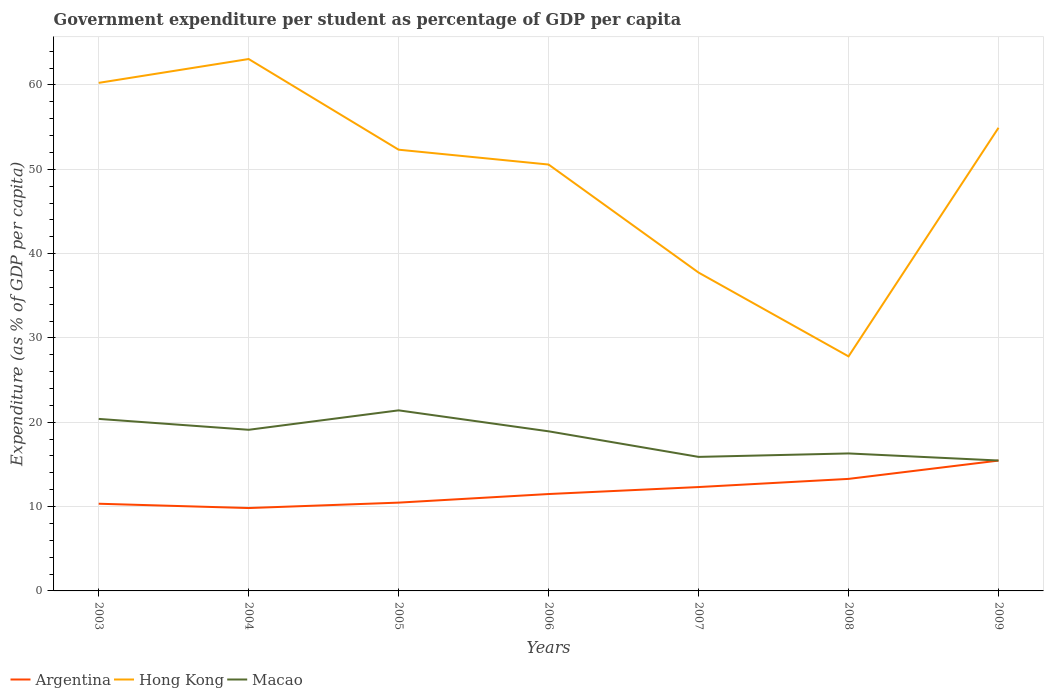Across all years, what is the maximum percentage of expenditure per student in Argentina?
Offer a very short reply. 9.83. In which year was the percentage of expenditure per student in Hong Kong maximum?
Offer a terse response. 2008. What is the total percentage of expenditure per student in Macao in the graph?
Ensure brevity in your answer.  -2.3. What is the difference between the highest and the second highest percentage of expenditure per student in Hong Kong?
Make the answer very short. 35.26. What is the difference between the highest and the lowest percentage of expenditure per student in Argentina?
Your answer should be compact. 3. Is the percentage of expenditure per student in Hong Kong strictly greater than the percentage of expenditure per student in Macao over the years?
Give a very brief answer. No. How many lines are there?
Provide a short and direct response. 3. How many years are there in the graph?
Your response must be concise. 7. What is the difference between two consecutive major ticks on the Y-axis?
Provide a succinct answer. 10. Does the graph contain grids?
Ensure brevity in your answer.  Yes. What is the title of the graph?
Offer a very short reply. Government expenditure per student as percentage of GDP per capita. Does "Haiti" appear as one of the legend labels in the graph?
Your response must be concise. No. What is the label or title of the X-axis?
Offer a terse response. Years. What is the label or title of the Y-axis?
Offer a very short reply. Expenditure (as % of GDP per capita). What is the Expenditure (as % of GDP per capita) of Argentina in 2003?
Ensure brevity in your answer.  10.34. What is the Expenditure (as % of GDP per capita) in Hong Kong in 2003?
Offer a very short reply. 60.25. What is the Expenditure (as % of GDP per capita) in Macao in 2003?
Your answer should be compact. 20.4. What is the Expenditure (as % of GDP per capita) of Argentina in 2004?
Provide a succinct answer. 9.83. What is the Expenditure (as % of GDP per capita) in Hong Kong in 2004?
Make the answer very short. 63.07. What is the Expenditure (as % of GDP per capita) of Macao in 2004?
Provide a short and direct response. 19.11. What is the Expenditure (as % of GDP per capita) of Argentina in 2005?
Offer a terse response. 10.47. What is the Expenditure (as % of GDP per capita) in Hong Kong in 2005?
Your response must be concise. 52.32. What is the Expenditure (as % of GDP per capita) of Macao in 2005?
Provide a succinct answer. 21.41. What is the Expenditure (as % of GDP per capita) in Argentina in 2006?
Keep it short and to the point. 11.49. What is the Expenditure (as % of GDP per capita) of Hong Kong in 2006?
Offer a terse response. 50.56. What is the Expenditure (as % of GDP per capita) in Macao in 2006?
Make the answer very short. 18.93. What is the Expenditure (as % of GDP per capita) in Argentina in 2007?
Offer a very short reply. 12.32. What is the Expenditure (as % of GDP per capita) in Hong Kong in 2007?
Make the answer very short. 37.75. What is the Expenditure (as % of GDP per capita) in Macao in 2007?
Your answer should be very brief. 15.89. What is the Expenditure (as % of GDP per capita) in Argentina in 2008?
Ensure brevity in your answer.  13.29. What is the Expenditure (as % of GDP per capita) in Hong Kong in 2008?
Provide a short and direct response. 27.81. What is the Expenditure (as % of GDP per capita) of Macao in 2008?
Offer a terse response. 16.3. What is the Expenditure (as % of GDP per capita) in Argentina in 2009?
Offer a very short reply. 15.46. What is the Expenditure (as % of GDP per capita) of Hong Kong in 2009?
Offer a terse response. 54.92. What is the Expenditure (as % of GDP per capita) in Macao in 2009?
Your answer should be compact. 15.46. Across all years, what is the maximum Expenditure (as % of GDP per capita) in Argentina?
Provide a short and direct response. 15.46. Across all years, what is the maximum Expenditure (as % of GDP per capita) of Hong Kong?
Make the answer very short. 63.07. Across all years, what is the maximum Expenditure (as % of GDP per capita) in Macao?
Keep it short and to the point. 21.41. Across all years, what is the minimum Expenditure (as % of GDP per capita) of Argentina?
Offer a terse response. 9.83. Across all years, what is the minimum Expenditure (as % of GDP per capita) of Hong Kong?
Keep it short and to the point. 27.81. Across all years, what is the minimum Expenditure (as % of GDP per capita) of Macao?
Ensure brevity in your answer.  15.46. What is the total Expenditure (as % of GDP per capita) of Argentina in the graph?
Provide a succinct answer. 83.19. What is the total Expenditure (as % of GDP per capita) in Hong Kong in the graph?
Ensure brevity in your answer.  346.69. What is the total Expenditure (as % of GDP per capita) of Macao in the graph?
Provide a short and direct response. 127.51. What is the difference between the Expenditure (as % of GDP per capita) in Argentina in 2003 and that in 2004?
Provide a short and direct response. 0.51. What is the difference between the Expenditure (as % of GDP per capita) of Hong Kong in 2003 and that in 2004?
Your response must be concise. -2.83. What is the difference between the Expenditure (as % of GDP per capita) in Macao in 2003 and that in 2004?
Offer a very short reply. 1.29. What is the difference between the Expenditure (as % of GDP per capita) of Argentina in 2003 and that in 2005?
Make the answer very short. -0.13. What is the difference between the Expenditure (as % of GDP per capita) in Hong Kong in 2003 and that in 2005?
Offer a very short reply. 7.93. What is the difference between the Expenditure (as % of GDP per capita) of Macao in 2003 and that in 2005?
Your answer should be very brief. -1.01. What is the difference between the Expenditure (as % of GDP per capita) of Argentina in 2003 and that in 2006?
Give a very brief answer. -1.15. What is the difference between the Expenditure (as % of GDP per capita) of Hong Kong in 2003 and that in 2006?
Your answer should be compact. 9.69. What is the difference between the Expenditure (as % of GDP per capita) in Macao in 2003 and that in 2006?
Offer a terse response. 1.47. What is the difference between the Expenditure (as % of GDP per capita) in Argentina in 2003 and that in 2007?
Give a very brief answer. -1.98. What is the difference between the Expenditure (as % of GDP per capita) of Hong Kong in 2003 and that in 2007?
Your answer should be very brief. 22.5. What is the difference between the Expenditure (as % of GDP per capita) in Macao in 2003 and that in 2007?
Make the answer very short. 4.5. What is the difference between the Expenditure (as % of GDP per capita) in Argentina in 2003 and that in 2008?
Offer a very short reply. -2.95. What is the difference between the Expenditure (as % of GDP per capita) in Hong Kong in 2003 and that in 2008?
Your answer should be compact. 32.44. What is the difference between the Expenditure (as % of GDP per capita) of Macao in 2003 and that in 2008?
Your answer should be compact. 4.1. What is the difference between the Expenditure (as % of GDP per capita) in Argentina in 2003 and that in 2009?
Provide a succinct answer. -5.12. What is the difference between the Expenditure (as % of GDP per capita) in Hong Kong in 2003 and that in 2009?
Your answer should be compact. 5.33. What is the difference between the Expenditure (as % of GDP per capita) in Macao in 2003 and that in 2009?
Offer a very short reply. 4.93. What is the difference between the Expenditure (as % of GDP per capita) in Argentina in 2004 and that in 2005?
Provide a short and direct response. -0.64. What is the difference between the Expenditure (as % of GDP per capita) in Hong Kong in 2004 and that in 2005?
Keep it short and to the point. 10.75. What is the difference between the Expenditure (as % of GDP per capita) of Macao in 2004 and that in 2005?
Offer a very short reply. -2.3. What is the difference between the Expenditure (as % of GDP per capita) in Argentina in 2004 and that in 2006?
Provide a succinct answer. -1.66. What is the difference between the Expenditure (as % of GDP per capita) in Hong Kong in 2004 and that in 2006?
Offer a very short reply. 12.51. What is the difference between the Expenditure (as % of GDP per capita) of Macao in 2004 and that in 2006?
Provide a succinct answer. 0.18. What is the difference between the Expenditure (as % of GDP per capita) of Argentina in 2004 and that in 2007?
Your response must be concise. -2.49. What is the difference between the Expenditure (as % of GDP per capita) in Hong Kong in 2004 and that in 2007?
Provide a succinct answer. 25.32. What is the difference between the Expenditure (as % of GDP per capita) in Macao in 2004 and that in 2007?
Keep it short and to the point. 3.21. What is the difference between the Expenditure (as % of GDP per capita) of Argentina in 2004 and that in 2008?
Your answer should be very brief. -3.46. What is the difference between the Expenditure (as % of GDP per capita) of Hong Kong in 2004 and that in 2008?
Your answer should be compact. 35.26. What is the difference between the Expenditure (as % of GDP per capita) in Macao in 2004 and that in 2008?
Your response must be concise. 2.8. What is the difference between the Expenditure (as % of GDP per capita) in Argentina in 2004 and that in 2009?
Provide a succinct answer. -5.63. What is the difference between the Expenditure (as % of GDP per capita) of Hong Kong in 2004 and that in 2009?
Keep it short and to the point. 8.15. What is the difference between the Expenditure (as % of GDP per capita) of Macao in 2004 and that in 2009?
Your answer should be compact. 3.64. What is the difference between the Expenditure (as % of GDP per capita) of Argentina in 2005 and that in 2006?
Give a very brief answer. -1.02. What is the difference between the Expenditure (as % of GDP per capita) in Hong Kong in 2005 and that in 2006?
Offer a terse response. 1.76. What is the difference between the Expenditure (as % of GDP per capita) of Macao in 2005 and that in 2006?
Give a very brief answer. 2.49. What is the difference between the Expenditure (as % of GDP per capita) of Argentina in 2005 and that in 2007?
Offer a terse response. -1.85. What is the difference between the Expenditure (as % of GDP per capita) in Hong Kong in 2005 and that in 2007?
Provide a succinct answer. 14.57. What is the difference between the Expenditure (as % of GDP per capita) in Macao in 2005 and that in 2007?
Make the answer very short. 5.52. What is the difference between the Expenditure (as % of GDP per capita) in Argentina in 2005 and that in 2008?
Keep it short and to the point. -2.81. What is the difference between the Expenditure (as % of GDP per capita) in Hong Kong in 2005 and that in 2008?
Offer a terse response. 24.51. What is the difference between the Expenditure (as % of GDP per capita) in Macao in 2005 and that in 2008?
Give a very brief answer. 5.11. What is the difference between the Expenditure (as % of GDP per capita) in Argentina in 2005 and that in 2009?
Your answer should be compact. -4.98. What is the difference between the Expenditure (as % of GDP per capita) of Hong Kong in 2005 and that in 2009?
Offer a very short reply. -2.6. What is the difference between the Expenditure (as % of GDP per capita) of Macao in 2005 and that in 2009?
Offer a very short reply. 5.95. What is the difference between the Expenditure (as % of GDP per capita) in Argentina in 2006 and that in 2007?
Offer a very short reply. -0.83. What is the difference between the Expenditure (as % of GDP per capita) of Hong Kong in 2006 and that in 2007?
Keep it short and to the point. 12.81. What is the difference between the Expenditure (as % of GDP per capita) of Macao in 2006 and that in 2007?
Your answer should be compact. 3.03. What is the difference between the Expenditure (as % of GDP per capita) of Argentina in 2006 and that in 2008?
Offer a very short reply. -1.8. What is the difference between the Expenditure (as % of GDP per capita) of Hong Kong in 2006 and that in 2008?
Offer a very short reply. 22.75. What is the difference between the Expenditure (as % of GDP per capita) of Macao in 2006 and that in 2008?
Your response must be concise. 2.62. What is the difference between the Expenditure (as % of GDP per capita) of Argentina in 2006 and that in 2009?
Keep it short and to the point. -3.97. What is the difference between the Expenditure (as % of GDP per capita) in Hong Kong in 2006 and that in 2009?
Provide a short and direct response. -4.36. What is the difference between the Expenditure (as % of GDP per capita) of Macao in 2006 and that in 2009?
Your answer should be compact. 3.46. What is the difference between the Expenditure (as % of GDP per capita) of Argentina in 2007 and that in 2008?
Provide a short and direct response. -0.97. What is the difference between the Expenditure (as % of GDP per capita) of Hong Kong in 2007 and that in 2008?
Your answer should be compact. 9.94. What is the difference between the Expenditure (as % of GDP per capita) of Macao in 2007 and that in 2008?
Give a very brief answer. -0.41. What is the difference between the Expenditure (as % of GDP per capita) in Argentina in 2007 and that in 2009?
Make the answer very short. -3.14. What is the difference between the Expenditure (as % of GDP per capita) in Hong Kong in 2007 and that in 2009?
Keep it short and to the point. -17.17. What is the difference between the Expenditure (as % of GDP per capita) of Macao in 2007 and that in 2009?
Ensure brevity in your answer.  0.43. What is the difference between the Expenditure (as % of GDP per capita) of Argentina in 2008 and that in 2009?
Offer a terse response. -2.17. What is the difference between the Expenditure (as % of GDP per capita) of Hong Kong in 2008 and that in 2009?
Offer a very short reply. -27.11. What is the difference between the Expenditure (as % of GDP per capita) of Macao in 2008 and that in 2009?
Ensure brevity in your answer.  0.84. What is the difference between the Expenditure (as % of GDP per capita) in Argentina in 2003 and the Expenditure (as % of GDP per capita) in Hong Kong in 2004?
Your answer should be compact. -52.74. What is the difference between the Expenditure (as % of GDP per capita) in Argentina in 2003 and the Expenditure (as % of GDP per capita) in Macao in 2004?
Keep it short and to the point. -8.77. What is the difference between the Expenditure (as % of GDP per capita) in Hong Kong in 2003 and the Expenditure (as % of GDP per capita) in Macao in 2004?
Make the answer very short. 41.14. What is the difference between the Expenditure (as % of GDP per capita) in Argentina in 2003 and the Expenditure (as % of GDP per capita) in Hong Kong in 2005?
Offer a terse response. -41.98. What is the difference between the Expenditure (as % of GDP per capita) in Argentina in 2003 and the Expenditure (as % of GDP per capita) in Macao in 2005?
Provide a short and direct response. -11.07. What is the difference between the Expenditure (as % of GDP per capita) in Hong Kong in 2003 and the Expenditure (as % of GDP per capita) in Macao in 2005?
Provide a short and direct response. 38.83. What is the difference between the Expenditure (as % of GDP per capita) of Argentina in 2003 and the Expenditure (as % of GDP per capita) of Hong Kong in 2006?
Offer a very short reply. -40.22. What is the difference between the Expenditure (as % of GDP per capita) of Argentina in 2003 and the Expenditure (as % of GDP per capita) of Macao in 2006?
Offer a very short reply. -8.59. What is the difference between the Expenditure (as % of GDP per capita) in Hong Kong in 2003 and the Expenditure (as % of GDP per capita) in Macao in 2006?
Offer a very short reply. 41.32. What is the difference between the Expenditure (as % of GDP per capita) of Argentina in 2003 and the Expenditure (as % of GDP per capita) of Hong Kong in 2007?
Your response must be concise. -27.41. What is the difference between the Expenditure (as % of GDP per capita) of Argentina in 2003 and the Expenditure (as % of GDP per capita) of Macao in 2007?
Provide a succinct answer. -5.56. What is the difference between the Expenditure (as % of GDP per capita) in Hong Kong in 2003 and the Expenditure (as % of GDP per capita) in Macao in 2007?
Keep it short and to the point. 44.35. What is the difference between the Expenditure (as % of GDP per capita) in Argentina in 2003 and the Expenditure (as % of GDP per capita) in Hong Kong in 2008?
Ensure brevity in your answer.  -17.47. What is the difference between the Expenditure (as % of GDP per capita) in Argentina in 2003 and the Expenditure (as % of GDP per capita) in Macao in 2008?
Offer a terse response. -5.96. What is the difference between the Expenditure (as % of GDP per capita) in Hong Kong in 2003 and the Expenditure (as % of GDP per capita) in Macao in 2008?
Your response must be concise. 43.94. What is the difference between the Expenditure (as % of GDP per capita) in Argentina in 2003 and the Expenditure (as % of GDP per capita) in Hong Kong in 2009?
Offer a very short reply. -44.58. What is the difference between the Expenditure (as % of GDP per capita) of Argentina in 2003 and the Expenditure (as % of GDP per capita) of Macao in 2009?
Offer a terse response. -5.13. What is the difference between the Expenditure (as % of GDP per capita) of Hong Kong in 2003 and the Expenditure (as % of GDP per capita) of Macao in 2009?
Ensure brevity in your answer.  44.78. What is the difference between the Expenditure (as % of GDP per capita) of Argentina in 2004 and the Expenditure (as % of GDP per capita) of Hong Kong in 2005?
Your answer should be compact. -42.49. What is the difference between the Expenditure (as % of GDP per capita) in Argentina in 2004 and the Expenditure (as % of GDP per capita) in Macao in 2005?
Give a very brief answer. -11.59. What is the difference between the Expenditure (as % of GDP per capita) of Hong Kong in 2004 and the Expenditure (as % of GDP per capita) of Macao in 2005?
Your answer should be very brief. 41.66. What is the difference between the Expenditure (as % of GDP per capita) in Argentina in 2004 and the Expenditure (as % of GDP per capita) in Hong Kong in 2006?
Keep it short and to the point. -40.73. What is the difference between the Expenditure (as % of GDP per capita) of Argentina in 2004 and the Expenditure (as % of GDP per capita) of Macao in 2006?
Give a very brief answer. -9.1. What is the difference between the Expenditure (as % of GDP per capita) of Hong Kong in 2004 and the Expenditure (as % of GDP per capita) of Macao in 2006?
Your response must be concise. 44.15. What is the difference between the Expenditure (as % of GDP per capita) in Argentina in 2004 and the Expenditure (as % of GDP per capita) in Hong Kong in 2007?
Provide a short and direct response. -27.92. What is the difference between the Expenditure (as % of GDP per capita) in Argentina in 2004 and the Expenditure (as % of GDP per capita) in Macao in 2007?
Give a very brief answer. -6.07. What is the difference between the Expenditure (as % of GDP per capita) of Hong Kong in 2004 and the Expenditure (as % of GDP per capita) of Macao in 2007?
Provide a succinct answer. 47.18. What is the difference between the Expenditure (as % of GDP per capita) of Argentina in 2004 and the Expenditure (as % of GDP per capita) of Hong Kong in 2008?
Your answer should be compact. -17.98. What is the difference between the Expenditure (as % of GDP per capita) in Argentina in 2004 and the Expenditure (as % of GDP per capita) in Macao in 2008?
Your answer should be compact. -6.48. What is the difference between the Expenditure (as % of GDP per capita) in Hong Kong in 2004 and the Expenditure (as % of GDP per capita) in Macao in 2008?
Provide a short and direct response. 46.77. What is the difference between the Expenditure (as % of GDP per capita) of Argentina in 2004 and the Expenditure (as % of GDP per capita) of Hong Kong in 2009?
Offer a terse response. -45.09. What is the difference between the Expenditure (as % of GDP per capita) of Argentina in 2004 and the Expenditure (as % of GDP per capita) of Macao in 2009?
Keep it short and to the point. -5.64. What is the difference between the Expenditure (as % of GDP per capita) in Hong Kong in 2004 and the Expenditure (as % of GDP per capita) in Macao in 2009?
Offer a terse response. 47.61. What is the difference between the Expenditure (as % of GDP per capita) in Argentina in 2005 and the Expenditure (as % of GDP per capita) in Hong Kong in 2006?
Make the answer very short. -40.09. What is the difference between the Expenditure (as % of GDP per capita) in Argentina in 2005 and the Expenditure (as % of GDP per capita) in Macao in 2006?
Ensure brevity in your answer.  -8.46. What is the difference between the Expenditure (as % of GDP per capita) of Hong Kong in 2005 and the Expenditure (as % of GDP per capita) of Macao in 2006?
Provide a short and direct response. 33.4. What is the difference between the Expenditure (as % of GDP per capita) in Argentina in 2005 and the Expenditure (as % of GDP per capita) in Hong Kong in 2007?
Your answer should be compact. -27.28. What is the difference between the Expenditure (as % of GDP per capita) in Argentina in 2005 and the Expenditure (as % of GDP per capita) in Macao in 2007?
Provide a succinct answer. -5.42. What is the difference between the Expenditure (as % of GDP per capita) of Hong Kong in 2005 and the Expenditure (as % of GDP per capita) of Macao in 2007?
Ensure brevity in your answer.  36.43. What is the difference between the Expenditure (as % of GDP per capita) of Argentina in 2005 and the Expenditure (as % of GDP per capita) of Hong Kong in 2008?
Your answer should be compact. -17.34. What is the difference between the Expenditure (as % of GDP per capita) of Argentina in 2005 and the Expenditure (as % of GDP per capita) of Macao in 2008?
Give a very brief answer. -5.83. What is the difference between the Expenditure (as % of GDP per capita) in Hong Kong in 2005 and the Expenditure (as % of GDP per capita) in Macao in 2008?
Provide a short and direct response. 36.02. What is the difference between the Expenditure (as % of GDP per capita) of Argentina in 2005 and the Expenditure (as % of GDP per capita) of Hong Kong in 2009?
Make the answer very short. -44.45. What is the difference between the Expenditure (as % of GDP per capita) in Argentina in 2005 and the Expenditure (as % of GDP per capita) in Macao in 2009?
Your answer should be compact. -4.99. What is the difference between the Expenditure (as % of GDP per capita) of Hong Kong in 2005 and the Expenditure (as % of GDP per capita) of Macao in 2009?
Provide a succinct answer. 36.86. What is the difference between the Expenditure (as % of GDP per capita) of Argentina in 2006 and the Expenditure (as % of GDP per capita) of Hong Kong in 2007?
Your answer should be very brief. -26.26. What is the difference between the Expenditure (as % of GDP per capita) of Argentina in 2006 and the Expenditure (as % of GDP per capita) of Macao in 2007?
Ensure brevity in your answer.  -4.41. What is the difference between the Expenditure (as % of GDP per capita) in Hong Kong in 2006 and the Expenditure (as % of GDP per capita) in Macao in 2007?
Your answer should be compact. 34.67. What is the difference between the Expenditure (as % of GDP per capita) in Argentina in 2006 and the Expenditure (as % of GDP per capita) in Hong Kong in 2008?
Give a very brief answer. -16.32. What is the difference between the Expenditure (as % of GDP per capita) in Argentina in 2006 and the Expenditure (as % of GDP per capita) in Macao in 2008?
Offer a terse response. -4.81. What is the difference between the Expenditure (as % of GDP per capita) in Hong Kong in 2006 and the Expenditure (as % of GDP per capita) in Macao in 2008?
Your answer should be compact. 34.26. What is the difference between the Expenditure (as % of GDP per capita) in Argentina in 2006 and the Expenditure (as % of GDP per capita) in Hong Kong in 2009?
Make the answer very short. -43.43. What is the difference between the Expenditure (as % of GDP per capita) in Argentina in 2006 and the Expenditure (as % of GDP per capita) in Macao in 2009?
Make the answer very short. -3.98. What is the difference between the Expenditure (as % of GDP per capita) of Hong Kong in 2006 and the Expenditure (as % of GDP per capita) of Macao in 2009?
Your response must be concise. 35.1. What is the difference between the Expenditure (as % of GDP per capita) in Argentina in 2007 and the Expenditure (as % of GDP per capita) in Hong Kong in 2008?
Provide a succinct answer. -15.49. What is the difference between the Expenditure (as % of GDP per capita) in Argentina in 2007 and the Expenditure (as % of GDP per capita) in Macao in 2008?
Make the answer very short. -3.99. What is the difference between the Expenditure (as % of GDP per capita) of Hong Kong in 2007 and the Expenditure (as % of GDP per capita) of Macao in 2008?
Your response must be concise. 21.45. What is the difference between the Expenditure (as % of GDP per capita) in Argentina in 2007 and the Expenditure (as % of GDP per capita) in Hong Kong in 2009?
Provide a short and direct response. -42.6. What is the difference between the Expenditure (as % of GDP per capita) of Argentina in 2007 and the Expenditure (as % of GDP per capita) of Macao in 2009?
Provide a succinct answer. -3.15. What is the difference between the Expenditure (as % of GDP per capita) of Hong Kong in 2007 and the Expenditure (as % of GDP per capita) of Macao in 2009?
Provide a succinct answer. 22.29. What is the difference between the Expenditure (as % of GDP per capita) in Argentina in 2008 and the Expenditure (as % of GDP per capita) in Hong Kong in 2009?
Offer a very short reply. -41.64. What is the difference between the Expenditure (as % of GDP per capita) of Argentina in 2008 and the Expenditure (as % of GDP per capita) of Macao in 2009?
Provide a succinct answer. -2.18. What is the difference between the Expenditure (as % of GDP per capita) in Hong Kong in 2008 and the Expenditure (as % of GDP per capita) in Macao in 2009?
Offer a terse response. 12.35. What is the average Expenditure (as % of GDP per capita) in Argentina per year?
Your response must be concise. 11.88. What is the average Expenditure (as % of GDP per capita) in Hong Kong per year?
Offer a very short reply. 49.53. What is the average Expenditure (as % of GDP per capita) of Macao per year?
Offer a very short reply. 18.22. In the year 2003, what is the difference between the Expenditure (as % of GDP per capita) in Argentina and Expenditure (as % of GDP per capita) in Hong Kong?
Offer a terse response. -49.91. In the year 2003, what is the difference between the Expenditure (as % of GDP per capita) in Argentina and Expenditure (as % of GDP per capita) in Macao?
Provide a short and direct response. -10.06. In the year 2003, what is the difference between the Expenditure (as % of GDP per capita) in Hong Kong and Expenditure (as % of GDP per capita) in Macao?
Offer a terse response. 39.85. In the year 2004, what is the difference between the Expenditure (as % of GDP per capita) in Argentina and Expenditure (as % of GDP per capita) in Hong Kong?
Make the answer very short. -53.25. In the year 2004, what is the difference between the Expenditure (as % of GDP per capita) in Argentina and Expenditure (as % of GDP per capita) in Macao?
Offer a very short reply. -9.28. In the year 2004, what is the difference between the Expenditure (as % of GDP per capita) in Hong Kong and Expenditure (as % of GDP per capita) in Macao?
Keep it short and to the point. 43.97. In the year 2005, what is the difference between the Expenditure (as % of GDP per capita) in Argentina and Expenditure (as % of GDP per capita) in Hong Kong?
Keep it short and to the point. -41.85. In the year 2005, what is the difference between the Expenditure (as % of GDP per capita) of Argentina and Expenditure (as % of GDP per capita) of Macao?
Offer a terse response. -10.94. In the year 2005, what is the difference between the Expenditure (as % of GDP per capita) of Hong Kong and Expenditure (as % of GDP per capita) of Macao?
Offer a terse response. 30.91. In the year 2006, what is the difference between the Expenditure (as % of GDP per capita) in Argentina and Expenditure (as % of GDP per capita) in Hong Kong?
Your answer should be very brief. -39.07. In the year 2006, what is the difference between the Expenditure (as % of GDP per capita) in Argentina and Expenditure (as % of GDP per capita) in Macao?
Your answer should be very brief. -7.44. In the year 2006, what is the difference between the Expenditure (as % of GDP per capita) in Hong Kong and Expenditure (as % of GDP per capita) in Macao?
Your answer should be very brief. 31.64. In the year 2007, what is the difference between the Expenditure (as % of GDP per capita) of Argentina and Expenditure (as % of GDP per capita) of Hong Kong?
Provide a short and direct response. -25.43. In the year 2007, what is the difference between the Expenditure (as % of GDP per capita) in Argentina and Expenditure (as % of GDP per capita) in Macao?
Your answer should be very brief. -3.58. In the year 2007, what is the difference between the Expenditure (as % of GDP per capita) in Hong Kong and Expenditure (as % of GDP per capita) in Macao?
Your answer should be very brief. 21.86. In the year 2008, what is the difference between the Expenditure (as % of GDP per capita) of Argentina and Expenditure (as % of GDP per capita) of Hong Kong?
Ensure brevity in your answer.  -14.53. In the year 2008, what is the difference between the Expenditure (as % of GDP per capita) in Argentina and Expenditure (as % of GDP per capita) in Macao?
Your response must be concise. -3.02. In the year 2008, what is the difference between the Expenditure (as % of GDP per capita) of Hong Kong and Expenditure (as % of GDP per capita) of Macao?
Ensure brevity in your answer.  11.51. In the year 2009, what is the difference between the Expenditure (as % of GDP per capita) in Argentina and Expenditure (as % of GDP per capita) in Hong Kong?
Keep it short and to the point. -39.47. In the year 2009, what is the difference between the Expenditure (as % of GDP per capita) of Argentina and Expenditure (as % of GDP per capita) of Macao?
Your answer should be very brief. -0.01. In the year 2009, what is the difference between the Expenditure (as % of GDP per capita) in Hong Kong and Expenditure (as % of GDP per capita) in Macao?
Your response must be concise. 39.46. What is the ratio of the Expenditure (as % of GDP per capita) of Argentina in 2003 to that in 2004?
Your response must be concise. 1.05. What is the ratio of the Expenditure (as % of GDP per capita) in Hong Kong in 2003 to that in 2004?
Your answer should be compact. 0.96. What is the ratio of the Expenditure (as % of GDP per capita) of Macao in 2003 to that in 2004?
Offer a very short reply. 1.07. What is the ratio of the Expenditure (as % of GDP per capita) in Argentina in 2003 to that in 2005?
Your response must be concise. 0.99. What is the ratio of the Expenditure (as % of GDP per capita) of Hong Kong in 2003 to that in 2005?
Ensure brevity in your answer.  1.15. What is the ratio of the Expenditure (as % of GDP per capita) in Macao in 2003 to that in 2005?
Your answer should be very brief. 0.95. What is the ratio of the Expenditure (as % of GDP per capita) of Argentina in 2003 to that in 2006?
Your answer should be compact. 0.9. What is the ratio of the Expenditure (as % of GDP per capita) of Hong Kong in 2003 to that in 2006?
Ensure brevity in your answer.  1.19. What is the ratio of the Expenditure (as % of GDP per capita) in Macao in 2003 to that in 2006?
Keep it short and to the point. 1.08. What is the ratio of the Expenditure (as % of GDP per capita) in Argentina in 2003 to that in 2007?
Offer a terse response. 0.84. What is the ratio of the Expenditure (as % of GDP per capita) in Hong Kong in 2003 to that in 2007?
Provide a short and direct response. 1.6. What is the ratio of the Expenditure (as % of GDP per capita) of Macao in 2003 to that in 2007?
Make the answer very short. 1.28. What is the ratio of the Expenditure (as % of GDP per capita) in Argentina in 2003 to that in 2008?
Provide a short and direct response. 0.78. What is the ratio of the Expenditure (as % of GDP per capita) in Hong Kong in 2003 to that in 2008?
Your answer should be very brief. 2.17. What is the ratio of the Expenditure (as % of GDP per capita) in Macao in 2003 to that in 2008?
Your response must be concise. 1.25. What is the ratio of the Expenditure (as % of GDP per capita) of Argentina in 2003 to that in 2009?
Give a very brief answer. 0.67. What is the ratio of the Expenditure (as % of GDP per capita) in Hong Kong in 2003 to that in 2009?
Your response must be concise. 1.1. What is the ratio of the Expenditure (as % of GDP per capita) of Macao in 2003 to that in 2009?
Keep it short and to the point. 1.32. What is the ratio of the Expenditure (as % of GDP per capita) in Argentina in 2004 to that in 2005?
Provide a succinct answer. 0.94. What is the ratio of the Expenditure (as % of GDP per capita) in Hong Kong in 2004 to that in 2005?
Your answer should be compact. 1.21. What is the ratio of the Expenditure (as % of GDP per capita) in Macao in 2004 to that in 2005?
Provide a short and direct response. 0.89. What is the ratio of the Expenditure (as % of GDP per capita) of Argentina in 2004 to that in 2006?
Ensure brevity in your answer.  0.86. What is the ratio of the Expenditure (as % of GDP per capita) in Hong Kong in 2004 to that in 2006?
Provide a short and direct response. 1.25. What is the ratio of the Expenditure (as % of GDP per capita) of Macao in 2004 to that in 2006?
Ensure brevity in your answer.  1.01. What is the ratio of the Expenditure (as % of GDP per capita) of Argentina in 2004 to that in 2007?
Your answer should be very brief. 0.8. What is the ratio of the Expenditure (as % of GDP per capita) of Hong Kong in 2004 to that in 2007?
Offer a terse response. 1.67. What is the ratio of the Expenditure (as % of GDP per capita) of Macao in 2004 to that in 2007?
Your answer should be compact. 1.2. What is the ratio of the Expenditure (as % of GDP per capita) of Argentina in 2004 to that in 2008?
Your answer should be compact. 0.74. What is the ratio of the Expenditure (as % of GDP per capita) of Hong Kong in 2004 to that in 2008?
Offer a terse response. 2.27. What is the ratio of the Expenditure (as % of GDP per capita) of Macao in 2004 to that in 2008?
Give a very brief answer. 1.17. What is the ratio of the Expenditure (as % of GDP per capita) of Argentina in 2004 to that in 2009?
Your answer should be compact. 0.64. What is the ratio of the Expenditure (as % of GDP per capita) in Hong Kong in 2004 to that in 2009?
Your response must be concise. 1.15. What is the ratio of the Expenditure (as % of GDP per capita) of Macao in 2004 to that in 2009?
Make the answer very short. 1.24. What is the ratio of the Expenditure (as % of GDP per capita) in Argentina in 2005 to that in 2006?
Give a very brief answer. 0.91. What is the ratio of the Expenditure (as % of GDP per capita) in Hong Kong in 2005 to that in 2006?
Your answer should be very brief. 1.03. What is the ratio of the Expenditure (as % of GDP per capita) of Macao in 2005 to that in 2006?
Give a very brief answer. 1.13. What is the ratio of the Expenditure (as % of GDP per capita) in Argentina in 2005 to that in 2007?
Offer a terse response. 0.85. What is the ratio of the Expenditure (as % of GDP per capita) of Hong Kong in 2005 to that in 2007?
Ensure brevity in your answer.  1.39. What is the ratio of the Expenditure (as % of GDP per capita) of Macao in 2005 to that in 2007?
Your answer should be compact. 1.35. What is the ratio of the Expenditure (as % of GDP per capita) of Argentina in 2005 to that in 2008?
Your answer should be compact. 0.79. What is the ratio of the Expenditure (as % of GDP per capita) of Hong Kong in 2005 to that in 2008?
Give a very brief answer. 1.88. What is the ratio of the Expenditure (as % of GDP per capita) of Macao in 2005 to that in 2008?
Provide a succinct answer. 1.31. What is the ratio of the Expenditure (as % of GDP per capita) in Argentina in 2005 to that in 2009?
Ensure brevity in your answer.  0.68. What is the ratio of the Expenditure (as % of GDP per capita) in Hong Kong in 2005 to that in 2009?
Keep it short and to the point. 0.95. What is the ratio of the Expenditure (as % of GDP per capita) of Macao in 2005 to that in 2009?
Your answer should be very brief. 1.38. What is the ratio of the Expenditure (as % of GDP per capita) of Argentina in 2006 to that in 2007?
Provide a short and direct response. 0.93. What is the ratio of the Expenditure (as % of GDP per capita) of Hong Kong in 2006 to that in 2007?
Offer a terse response. 1.34. What is the ratio of the Expenditure (as % of GDP per capita) in Macao in 2006 to that in 2007?
Your answer should be compact. 1.19. What is the ratio of the Expenditure (as % of GDP per capita) of Argentina in 2006 to that in 2008?
Offer a terse response. 0.86. What is the ratio of the Expenditure (as % of GDP per capita) of Hong Kong in 2006 to that in 2008?
Provide a short and direct response. 1.82. What is the ratio of the Expenditure (as % of GDP per capita) in Macao in 2006 to that in 2008?
Provide a short and direct response. 1.16. What is the ratio of the Expenditure (as % of GDP per capita) of Argentina in 2006 to that in 2009?
Your answer should be compact. 0.74. What is the ratio of the Expenditure (as % of GDP per capita) of Hong Kong in 2006 to that in 2009?
Make the answer very short. 0.92. What is the ratio of the Expenditure (as % of GDP per capita) of Macao in 2006 to that in 2009?
Your response must be concise. 1.22. What is the ratio of the Expenditure (as % of GDP per capita) of Argentina in 2007 to that in 2008?
Offer a very short reply. 0.93. What is the ratio of the Expenditure (as % of GDP per capita) of Hong Kong in 2007 to that in 2008?
Make the answer very short. 1.36. What is the ratio of the Expenditure (as % of GDP per capita) in Macao in 2007 to that in 2008?
Give a very brief answer. 0.97. What is the ratio of the Expenditure (as % of GDP per capita) in Argentina in 2007 to that in 2009?
Ensure brevity in your answer.  0.8. What is the ratio of the Expenditure (as % of GDP per capita) of Hong Kong in 2007 to that in 2009?
Provide a short and direct response. 0.69. What is the ratio of the Expenditure (as % of GDP per capita) of Macao in 2007 to that in 2009?
Offer a terse response. 1.03. What is the ratio of the Expenditure (as % of GDP per capita) in Argentina in 2008 to that in 2009?
Offer a very short reply. 0.86. What is the ratio of the Expenditure (as % of GDP per capita) in Hong Kong in 2008 to that in 2009?
Offer a very short reply. 0.51. What is the ratio of the Expenditure (as % of GDP per capita) in Macao in 2008 to that in 2009?
Your answer should be compact. 1.05. What is the difference between the highest and the second highest Expenditure (as % of GDP per capita) of Argentina?
Provide a succinct answer. 2.17. What is the difference between the highest and the second highest Expenditure (as % of GDP per capita) in Hong Kong?
Give a very brief answer. 2.83. What is the difference between the highest and the lowest Expenditure (as % of GDP per capita) of Argentina?
Your answer should be compact. 5.63. What is the difference between the highest and the lowest Expenditure (as % of GDP per capita) of Hong Kong?
Make the answer very short. 35.26. What is the difference between the highest and the lowest Expenditure (as % of GDP per capita) in Macao?
Your answer should be very brief. 5.95. 